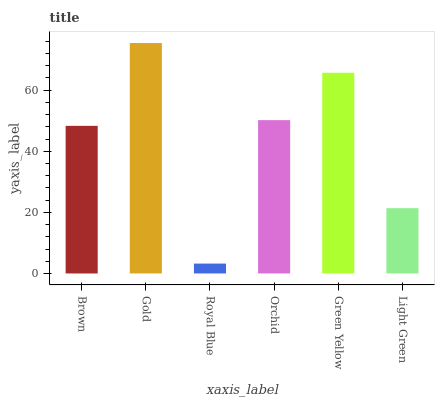Is Gold the minimum?
Answer yes or no. No. Is Royal Blue the maximum?
Answer yes or no. No. Is Gold greater than Royal Blue?
Answer yes or no. Yes. Is Royal Blue less than Gold?
Answer yes or no. Yes. Is Royal Blue greater than Gold?
Answer yes or no. No. Is Gold less than Royal Blue?
Answer yes or no. No. Is Orchid the high median?
Answer yes or no. Yes. Is Brown the low median?
Answer yes or no. Yes. Is Green Yellow the high median?
Answer yes or no. No. Is Green Yellow the low median?
Answer yes or no. No. 